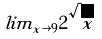Convert formula to latex. <formula><loc_0><loc_0><loc_500><loc_500>l i m _ { x \rightarrow 9 } 2 \sqrt { x }</formula> 